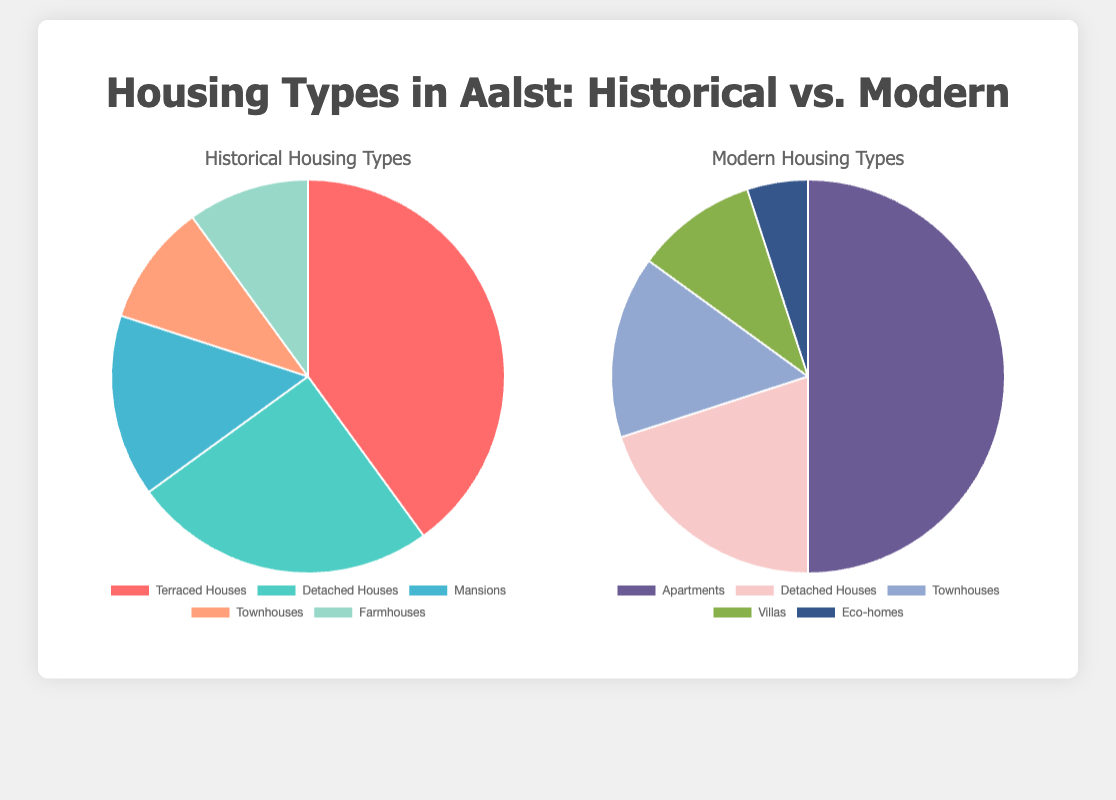What is the most common type of historical housing in Aalst by percentage? The chart for historical housing types shows the data distribution. The largest segment represents Terraced Houses which accounts for 40%.
Answer: Terraced Houses In modern housing, how many types of housing combined make up 65%? From the pie chart, Apartments represent 50%, and Detached Houses represent 20%. When summed up, these two types make 50% + 20% = 70%. Therefore, considering Townhouses with 15% would overshoot 65%, it indicates only Apartments and Detached Houses are needed to exceed 65%.
Answer: 2 types Which type of housing has a higher percentage in modern times compared to historical times, Detached Houses or Townhouses? By comparing both charts, Detached Houses make up 25% of historical housing and 20% of modern housing, thus less in modern times. Conversely, Townhouses make up 10% in historical and 15% in modern, showing an increase for modern times.
Answer: Townhouses What is the combined percentage of the least common housing types in historical and modern Aalst? The least common housing types in historical are Townhouses and Farmhouses both at 10%, and in modern, it's Eco-homes making up 5%. To find the combined percentage: 10% (Townhouses) + 10% (Farmhouses) + 5% (Eco-homes) = 25%.
Answer: 25% If one converted half of the historical Terraced Houses into modern Apartments, what percentage of housing would each type now represent in modern Aalst? Initially, there are 40% Terraced Houses and 50% Apartments. Converting half of 40% means 20% added to Apartments. Therefore, modern Apartments would now be 50% + 20% = 70% and remaining historical Terraced Houses 40% - 20% = 20%.
New percentages in modern Aalst: 
- Apartments: 70%
- Detached Houses: 20%
- Townhouses: 15%
- Villas: 10%
- Eco-homes: 5%
Answer: - Apartments: 70%
- Detached Houses: 20%
- Townhouses: 15%
- Villas: 10%
- Eco-homes: 5% What type of modern housing has almost the same percentage as Mansions in historical housing? The pie chart for historical housing shows Mansions make up 15%. In modern housing, Townhouses also represent 15%, making them the most comparable types percentage-wise.
Answer: Townhouses What is the difference in percentage points between the most common historical housing type and the most common modern housing type? The most common historical type is Terraced Houses at 40%, and the most common modern type is Apartments at 50%. The difference in percentage points is 50% - 40% = 10%.
Answer: 10% What percentage of all historical housing types combined are equal to the least common modern housing type? The least common modern type is Eco-homes at 5%. Historical types with 5% add up to Farmhouses and part of Townhouses: 10% (Farmhouses) + 5% slide from Townhouses (10%) combining to 15%. Therefore, the least common modern housing type equals exactly one whole Farmhouse part divided into equivalent measures.
Answer: 15% Which color represents the historical Detached Houses, and what is its percentage? The pie chart displays historical housing colors. The color representing Detached Houses (25%) is identified from the legend, and it shows as a shade of cyan/light blue.
Answer: cyan/light blue, 25% What is the total percentage of modern housing that consists of buildings other than apartments? From the modern housing pie chart; Apartments form 50%, the rest includes Detached Houses (20%), Townhouses (15%), Villas (10%), and Eco-homes (5%). Adding these gives 20% + 15% + 10% + 5% = 50%.
Answer: 50% 